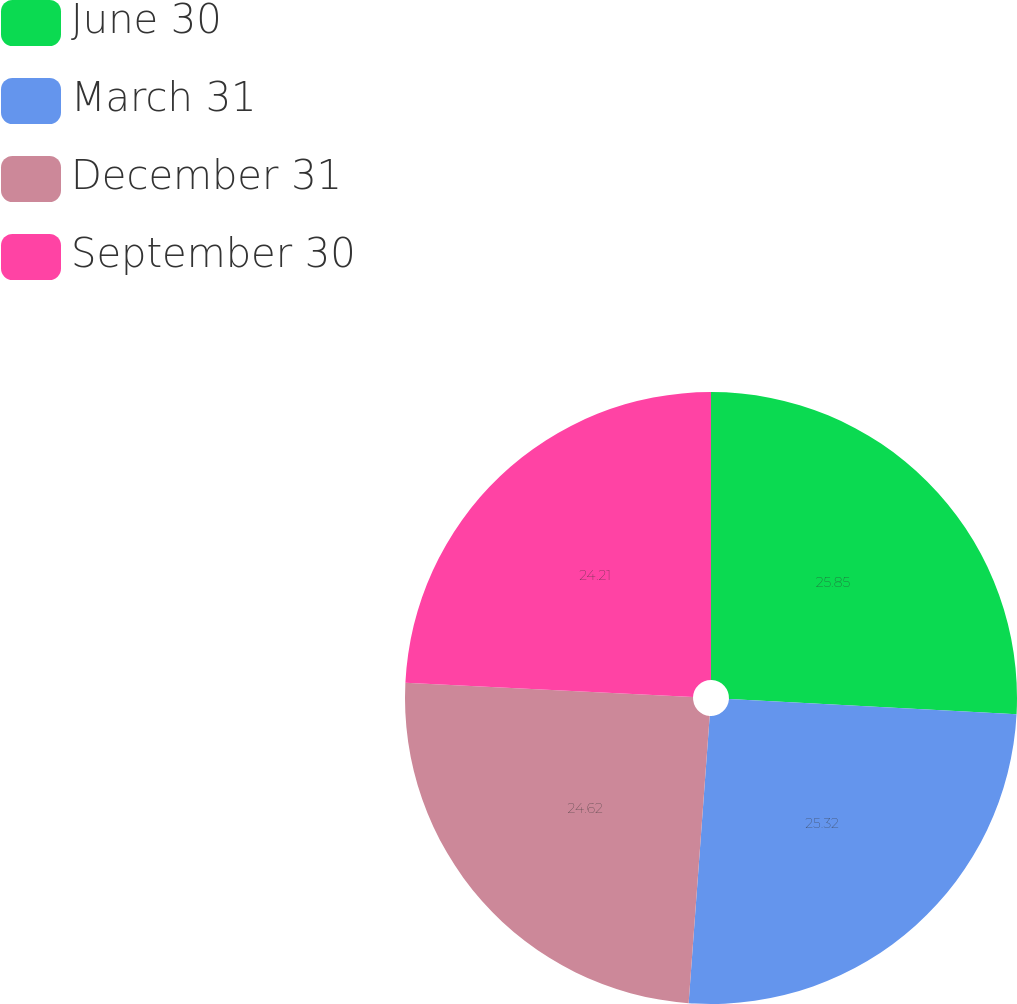Convert chart to OTSL. <chart><loc_0><loc_0><loc_500><loc_500><pie_chart><fcel>June 30<fcel>March 31<fcel>December 31<fcel>September 30<nl><fcel>25.84%<fcel>25.32%<fcel>24.62%<fcel>24.21%<nl></chart> 